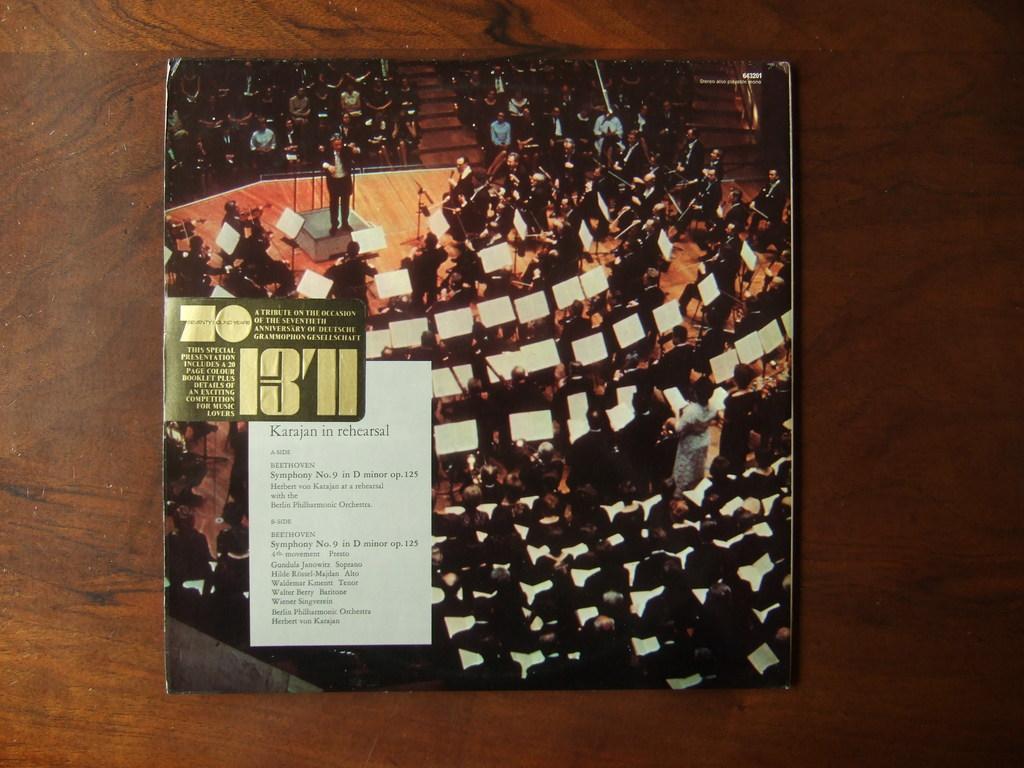What four numbers are on the cover?
Ensure brevity in your answer.  1371. What anniversary is this album celebrating?
Give a very brief answer. 70. 